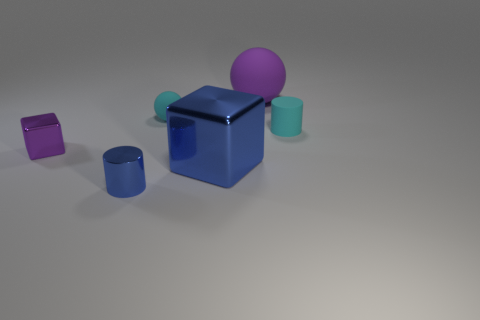What shape is the big purple object that is made of the same material as the cyan cylinder?
Your response must be concise. Sphere. Are there more purple things that are behind the purple block than blue metal cylinders?
Keep it short and to the point. No. How many large matte spheres are the same color as the metallic cylinder?
Offer a very short reply. 0. What number of other objects are the same color as the shiny cylinder?
Make the answer very short. 1. Is the number of small rubber cylinders greater than the number of cyan rubber objects?
Keep it short and to the point. No. What is the material of the cyan cylinder?
Offer a terse response. Rubber. Is the size of the metal thing that is to the right of the blue cylinder the same as the tiny matte sphere?
Give a very brief answer. No. What size is the blue object that is in front of the large blue metal thing?
Your answer should be very brief. Small. Is there any other thing that is made of the same material as the tiny sphere?
Give a very brief answer. Yes. What number of green matte cylinders are there?
Ensure brevity in your answer.  0. 